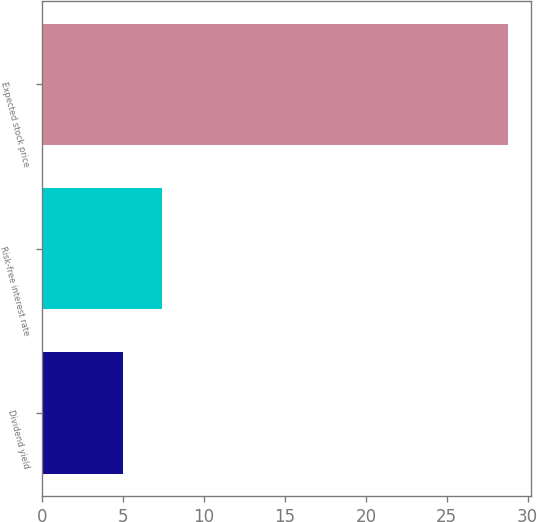Convert chart to OTSL. <chart><loc_0><loc_0><loc_500><loc_500><bar_chart><fcel>Dividend yield<fcel>Risk-free interest rate<fcel>Expected stock price<nl><fcel>5<fcel>7.38<fcel>28.76<nl></chart> 